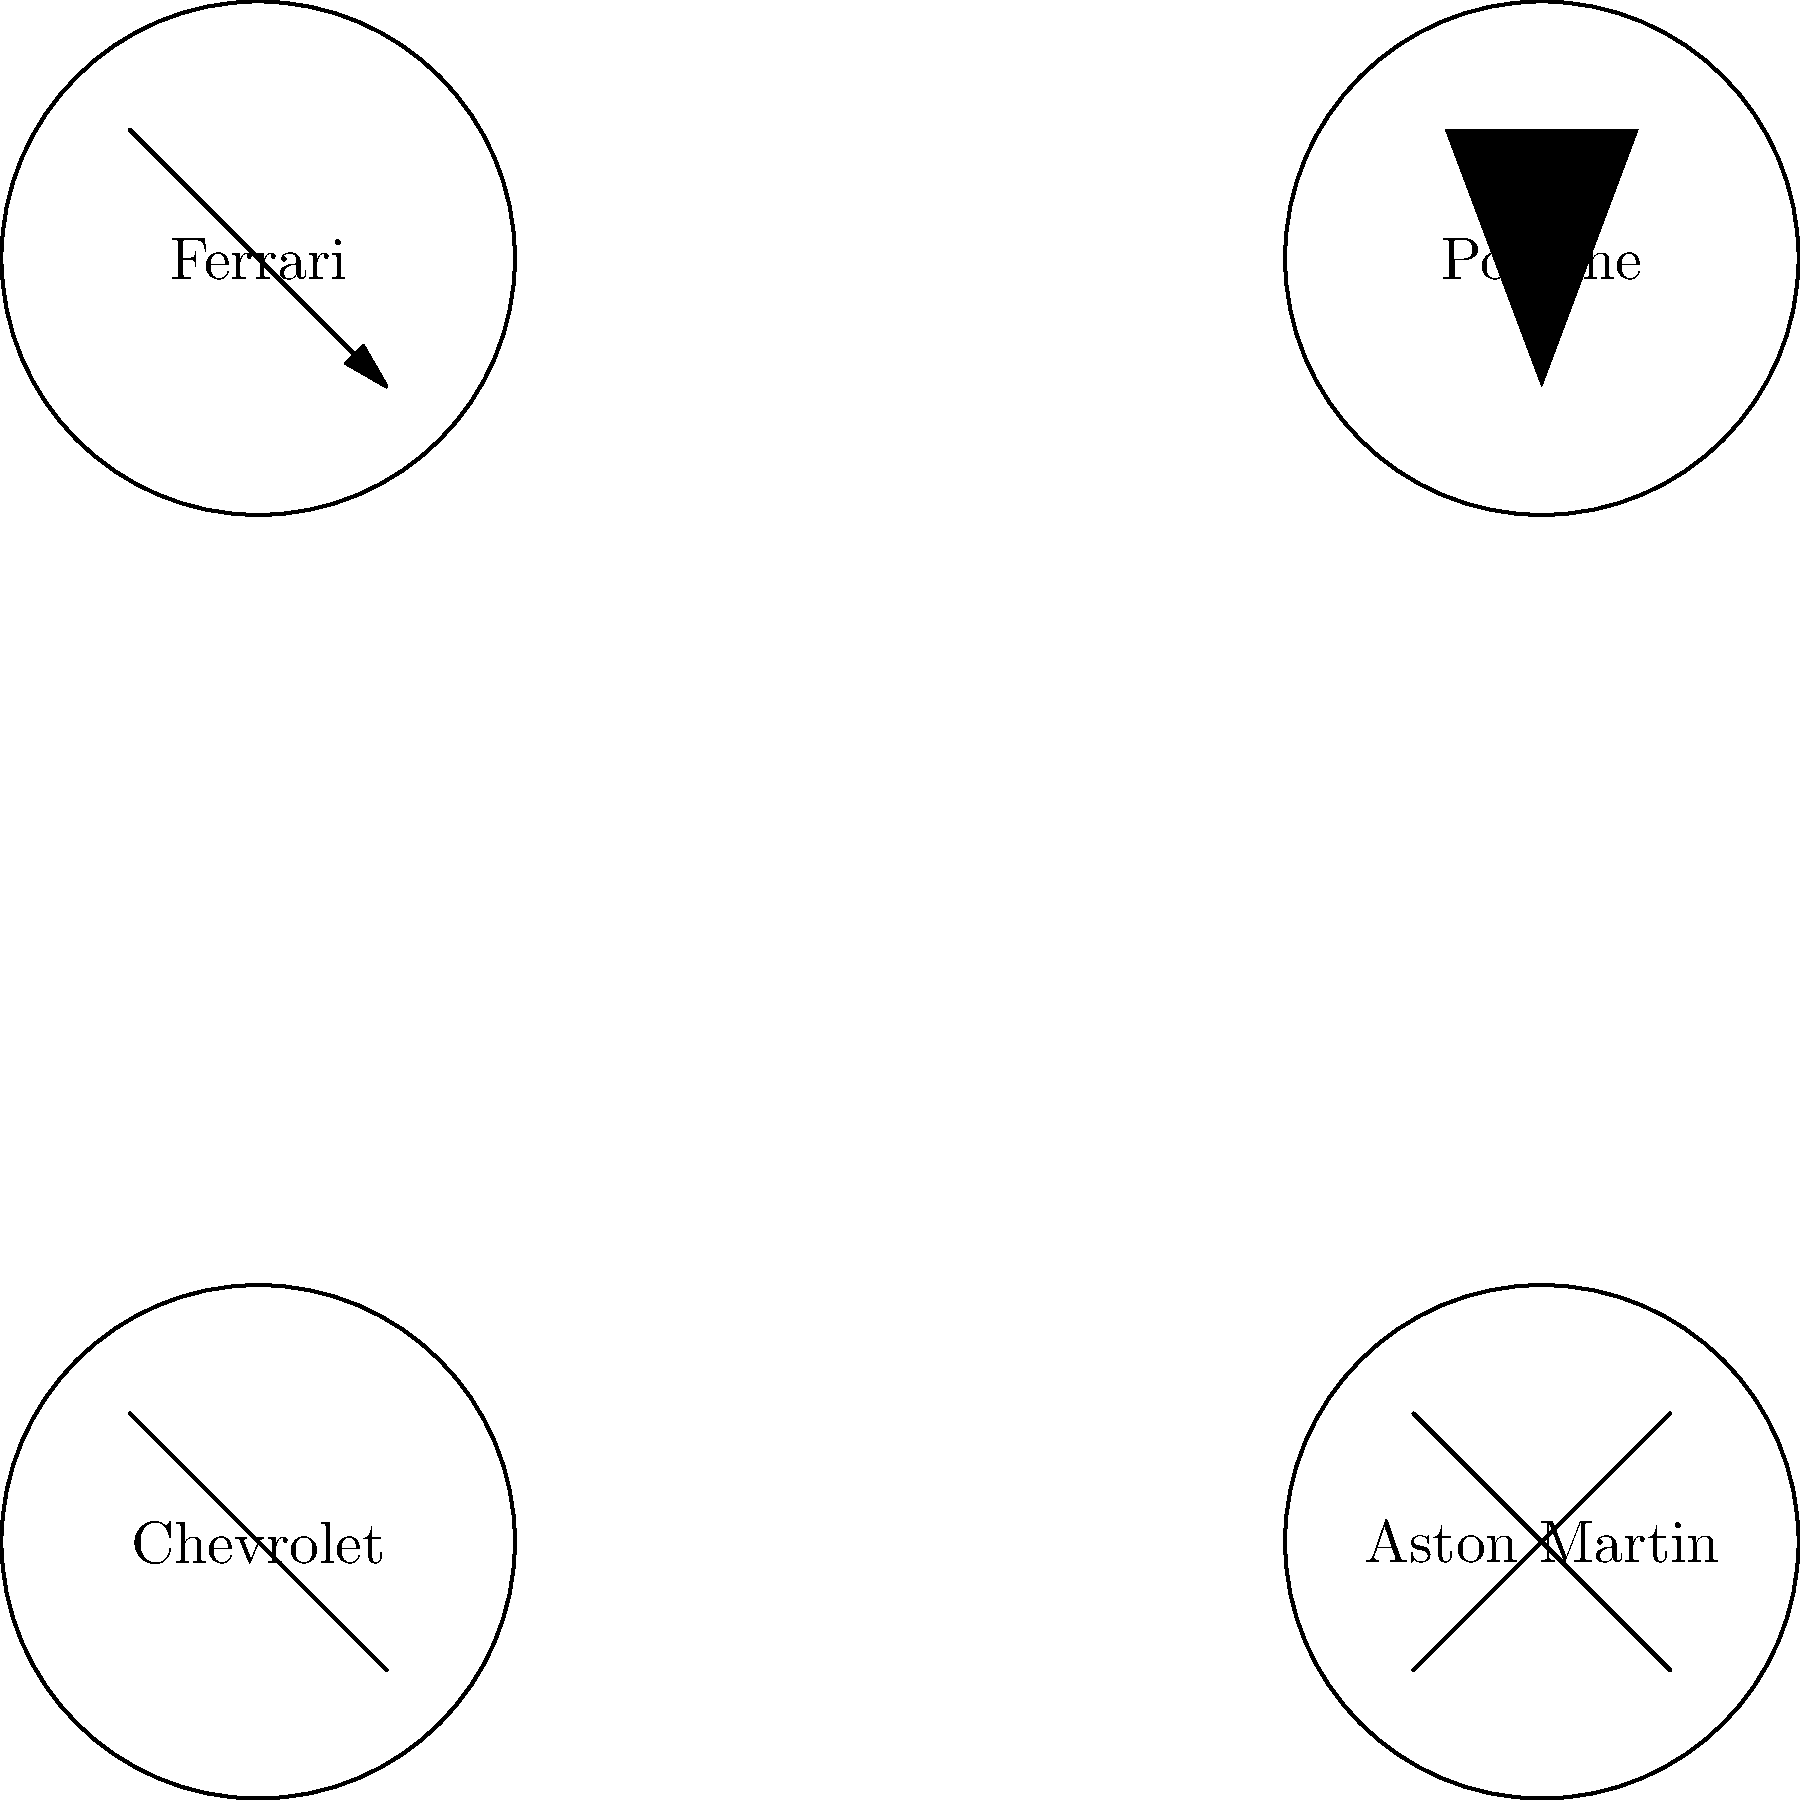Match the following classic car logos to their corresponding brands:

A. Prancing Horse
B. Shield with a cross
C. Bowtie
D. Wings To match the classic car logos to their corresponding brands, let's analyze each logo and its associated brand:

1. Prancing Horse:
   This iconic logo belongs to Ferrari. It features a black prancing horse on a yellow background, which has been the symbol of the Italian sports car manufacturer since 1929.

2. Shield with a cross:
   This emblem represents Porsche. The shield-shaped logo incorporates the coat of arms of Stuttgart, the company's hometown, which features a horse on its hind legs.

3. Bowtie:
   The bowtie logo is synonymous with Chevrolet. Introduced in 1913, this simple yet distinctive emblem has become one of the most recognizable automotive logos in the world.

4. Wings:
   The winged logo is associated with Aston Martin. The British luxury sports car manufacturer has used various iterations of wings in its emblem since the 1930s, symbolizing speed and freedom.

Matching the logos to the brands:
A. Prancing Horse - Ferrari
B. Shield with a cross - Porsche
C. Bowtie - Chevrolet
D. Wings - Aston Martin
Answer: A-Ferrari, B-Porsche, C-Chevrolet, D-Aston Martin 